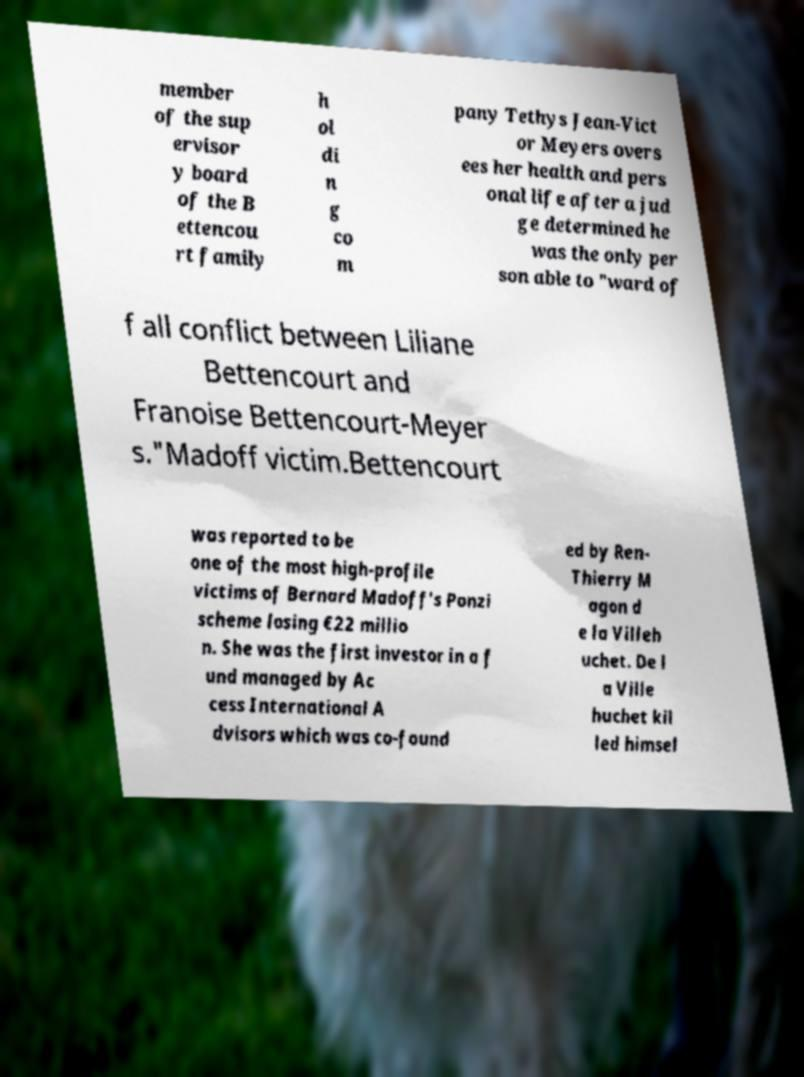Can you accurately transcribe the text from the provided image for me? member of the sup ervisor y board of the B ettencou rt family h ol di n g co m pany Tethys Jean-Vict or Meyers overs ees her health and pers onal life after a jud ge determined he was the only per son able to "ward of f all conflict between Liliane Bettencourt and Franoise Bettencourt-Meyer s."Madoff victim.Bettencourt was reported to be one of the most high-profile victims of Bernard Madoff's Ponzi scheme losing €22 millio n. She was the first investor in a f und managed by Ac cess International A dvisors which was co-found ed by Ren- Thierry M agon d e la Villeh uchet. De l a Ville huchet kil led himsel 